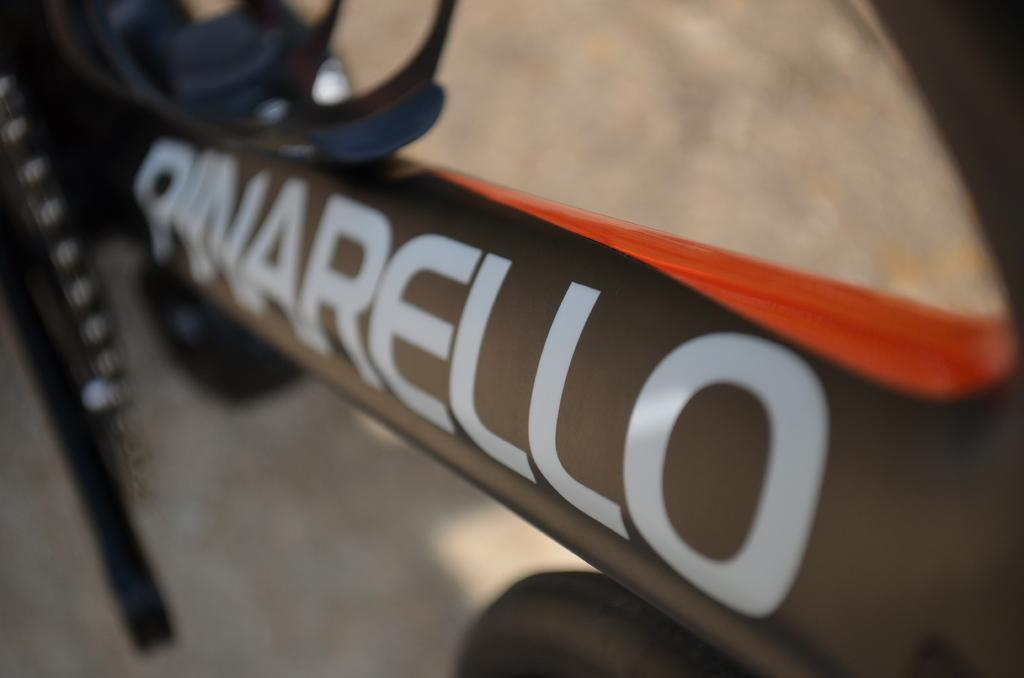What can be seen in the image with text on it? There is an object with text in the image. Can you describe the background of the image? The background of the image is blurred. What type of wound can be seen on the object with text in the image? There is no wound present on the object with text in the image. What class of students might be studying the object with text in the image? The image does not provide any information about students or classes, so it cannot be determined from the image. 